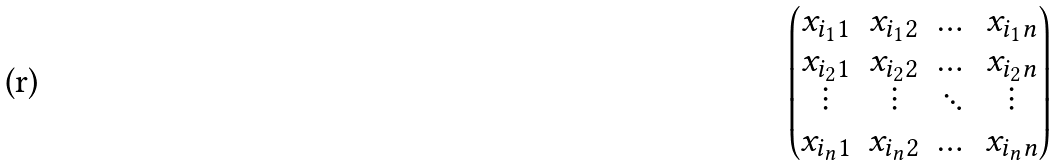Convert formula to latex. <formula><loc_0><loc_0><loc_500><loc_500>\begin{pmatrix} x _ { i _ { 1 } 1 } & x _ { i _ { 1 } 2 } & \dots & x _ { i _ { 1 } n } \\ x _ { i _ { 2 } 1 } & x _ { i _ { 2 } 2 } & \dots & x _ { i _ { 2 } n } \\ \vdots & \vdots & \ddots & \vdots \\ x _ { i _ { n } 1 } & x _ { i _ { n } 2 } & \dots & x _ { i _ { n } n } \end{pmatrix}</formula> 